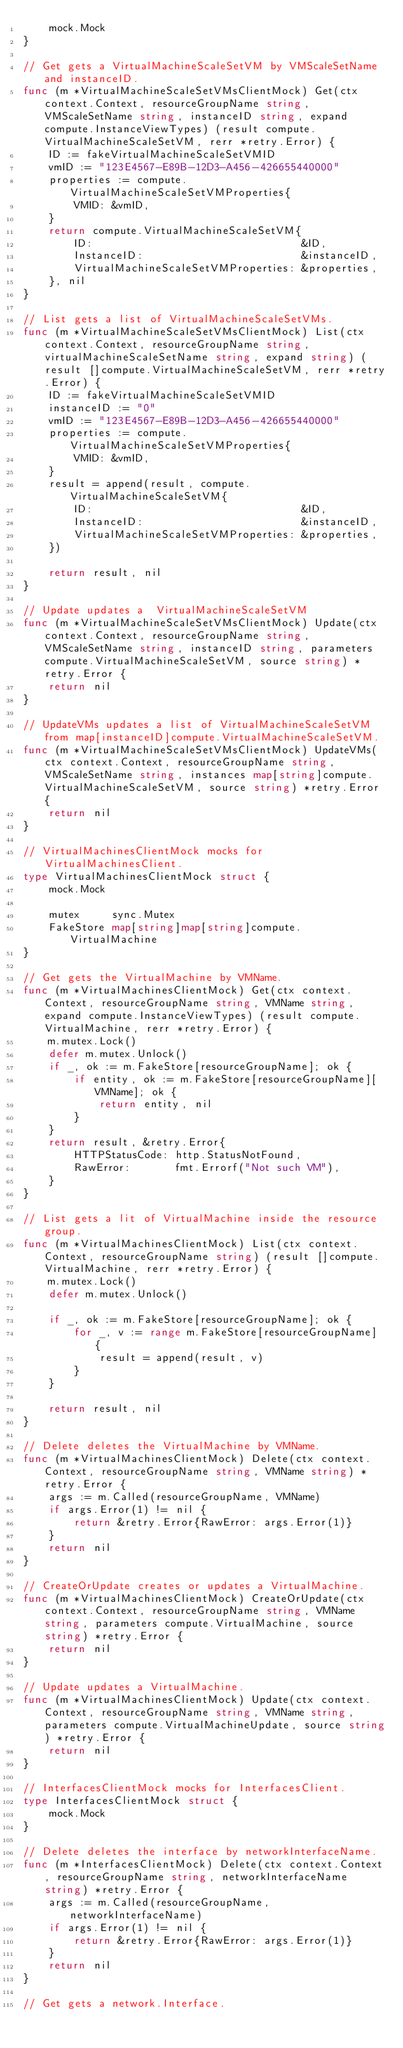Convert code to text. <code><loc_0><loc_0><loc_500><loc_500><_Go_>	mock.Mock
}

// Get gets a VirtualMachineScaleSetVM by VMScaleSetName and instanceID.
func (m *VirtualMachineScaleSetVMsClientMock) Get(ctx context.Context, resourceGroupName string, VMScaleSetName string, instanceID string, expand compute.InstanceViewTypes) (result compute.VirtualMachineScaleSetVM, rerr *retry.Error) {
	ID := fakeVirtualMachineScaleSetVMID
	vmID := "123E4567-E89B-12D3-A456-426655440000"
	properties := compute.VirtualMachineScaleSetVMProperties{
		VMID: &vmID,
	}
	return compute.VirtualMachineScaleSetVM{
		ID:                                 &ID,
		InstanceID:                         &instanceID,
		VirtualMachineScaleSetVMProperties: &properties,
	}, nil
}

// List gets a list of VirtualMachineScaleSetVMs.
func (m *VirtualMachineScaleSetVMsClientMock) List(ctx context.Context, resourceGroupName string, virtualMachineScaleSetName string, expand string) (result []compute.VirtualMachineScaleSetVM, rerr *retry.Error) {
	ID := fakeVirtualMachineScaleSetVMID
	instanceID := "0"
	vmID := "123E4567-E89B-12D3-A456-426655440000"
	properties := compute.VirtualMachineScaleSetVMProperties{
		VMID: &vmID,
	}
	result = append(result, compute.VirtualMachineScaleSetVM{
		ID:                                 &ID,
		InstanceID:                         &instanceID,
		VirtualMachineScaleSetVMProperties: &properties,
	})

	return result, nil
}

// Update updates a  VirtualMachineScaleSetVM
func (m *VirtualMachineScaleSetVMsClientMock) Update(ctx context.Context, resourceGroupName string, VMScaleSetName string, instanceID string, parameters compute.VirtualMachineScaleSetVM, source string) *retry.Error {
	return nil
}

// UpdateVMs updates a list of VirtualMachineScaleSetVM from map[instanceID]compute.VirtualMachineScaleSetVM.
func (m *VirtualMachineScaleSetVMsClientMock) UpdateVMs(ctx context.Context, resourceGroupName string, VMScaleSetName string, instances map[string]compute.VirtualMachineScaleSetVM, source string) *retry.Error {
	return nil
}

// VirtualMachinesClientMock mocks for VirtualMachinesClient.
type VirtualMachinesClientMock struct {
	mock.Mock

	mutex     sync.Mutex
	FakeStore map[string]map[string]compute.VirtualMachine
}

// Get gets the VirtualMachine by VMName.
func (m *VirtualMachinesClientMock) Get(ctx context.Context, resourceGroupName string, VMName string, expand compute.InstanceViewTypes) (result compute.VirtualMachine, rerr *retry.Error) {
	m.mutex.Lock()
	defer m.mutex.Unlock()
	if _, ok := m.FakeStore[resourceGroupName]; ok {
		if entity, ok := m.FakeStore[resourceGroupName][VMName]; ok {
			return entity, nil
		}
	}
	return result, &retry.Error{
		HTTPStatusCode: http.StatusNotFound,
		RawError:       fmt.Errorf("Not such VM"),
	}
}

// List gets a lit of VirtualMachine inside the resource group.
func (m *VirtualMachinesClientMock) List(ctx context.Context, resourceGroupName string) (result []compute.VirtualMachine, rerr *retry.Error) {
	m.mutex.Lock()
	defer m.mutex.Unlock()

	if _, ok := m.FakeStore[resourceGroupName]; ok {
		for _, v := range m.FakeStore[resourceGroupName] {
			result = append(result, v)
		}
	}

	return result, nil
}

// Delete deletes the VirtualMachine by VMName.
func (m *VirtualMachinesClientMock) Delete(ctx context.Context, resourceGroupName string, VMName string) *retry.Error {
	args := m.Called(resourceGroupName, VMName)
	if args.Error(1) != nil {
		return &retry.Error{RawError: args.Error(1)}
	}
	return nil
}

// CreateOrUpdate creates or updates a VirtualMachine.
func (m *VirtualMachinesClientMock) CreateOrUpdate(ctx context.Context, resourceGroupName string, VMName string, parameters compute.VirtualMachine, source string) *retry.Error {
	return nil
}

// Update updates a VirtualMachine.
func (m *VirtualMachinesClientMock) Update(ctx context.Context, resourceGroupName string, VMName string, parameters compute.VirtualMachineUpdate, source string) *retry.Error {
	return nil
}

// InterfacesClientMock mocks for InterfacesClient.
type InterfacesClientMock struct {
	mock.Mock
}

// Delete deletes the interface by networkInterfaceName.
func (m *InterfacesClientMock) Delete(ctx context.Context, resourceGroupName string, networkInterfaceName string) *retry.Error {
	args := m.Called(resourceGroupName, networkInterfaceName)
	if args.Error(1) != nil {
		return &retry.Error{RawError: args.Error(1)}
	}
	return nil
}

// Get gets a network.Interface.</code> 